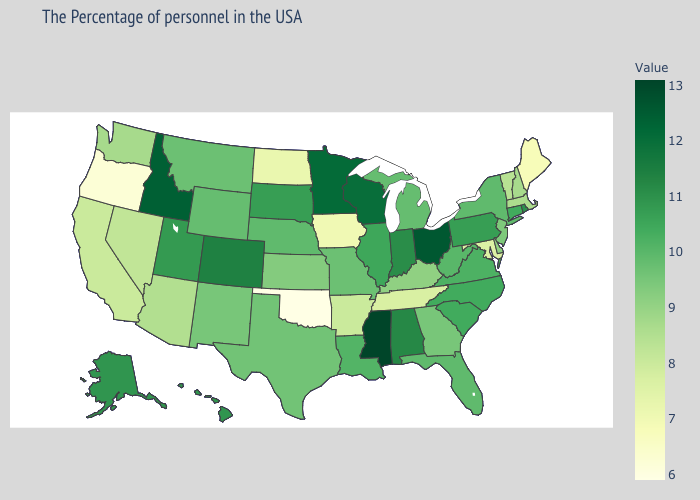Among the states that border Arkansas , which have the highest value?
Concise answer only. Mississippi. Does Rhode Island have the highest value in the Northeast?
Short answer required. Yes. Among the states that border Oregon , which have the highest value?
Write a very short answer. Idaho. Among the states that border Wisconsin , which have the lowest value?
Give a very brief answer. Iowa. Which states have the lowest value in the West?
Keep it brief. Oregon. Among the states that border Mississippi , which have the lowest value?
Short answer required. Tennessee. 